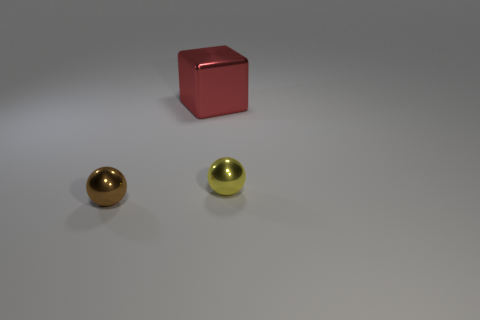Are the objects arranged in a particular pattern or order? The image shows three objects; one cube and two sphere-like cylinders placed in a triangular formation. The cube is in the foreground while the cylinders are spaced apart in the background. There is no evident specific pattern or intentional order, but the placement guides the viewer's eye from the larger, standout cube to the smaller, shiny cylinders. 